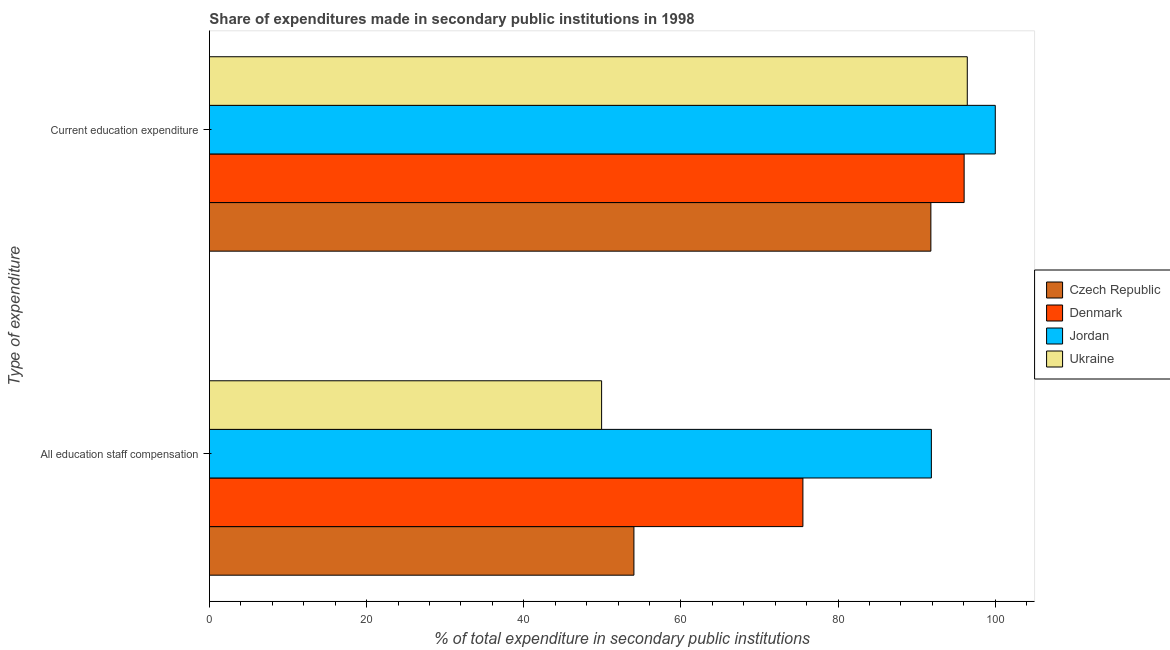How many different coloured bars are there?
Your answer should be very brief. 4. How many groups of bars are there?
Your answer should be very brief. 2. Are the number of bars on each tick of the Y-axis equal?
Ensure brevity in your answer.  Yes. How many bars are there on the 2nd tick from the top?
Your answer should be very brief. 4. How many bars are there on the 1st tick from the bottom?
Make the answer very short. 4. What is the label of the 1st group of bars from the top?
Your answer should be compact. Current education expenditure. What is the expenditure in staff compensation in Jordan?
Make the answer very short. 91.87. Across all countries, what is the minimum expenditure in education?
Make the answer very short. 91.8. In which country was the expenditure in education maximum?
Provide a short and direct response. Jordan. In which country was the expenditure in education minimum?
Make the answer very short. Czech Republic. What is the total expenditure in staff compensation in the graph?
Provide a succinct answer. 271.32. What is the difference between the expenditure in education in Czech Republic and that in Ukraine?
Provide a short and direct response. -4.63. What is the difference between the expenditure in education in Ukraine and the expenditure in staff compensation in Jordan?
Your answer should be compact. 4.57. What is the average expenditure in education per country?
Ensure brevity in your answer.  96.07. What is the difference between the expenditure in education and expenditure in staff compensation in Czech Republic?
Provide a short and direct response. 37.79. In how many countries, is the expenditure in staff compensation greater than 24 %?
Provide a short and direct response. 4. What is the ratio of the expenditure in staff compensation in Czech Republic to that in Ukraine?
Your answer should be compact. 1.08. Is the expenditure in staff compensation in Jordan less than that in Denmark?
Your answer should be very brief. No. In how many countries, is the expenditure in staff compensation greater than the average expenditure in staff compensation taken over all countries?
Keep it short and to the point. 2. Are the values on the major ticks of X-axis written in scientific E-notation?
Offer a very short reply. No. Where does the legend appear in the graph?
Provide a succinct answer. Center right. How many legend labels are there?
Ensure brevity in your answer.  4. What is the title of the graph?
Provide a short and direct response. Share of expenditures made in secondary public institutions in 1998. What is the label or title of the X-axis?
Provide a short and direct response. % of total expenditure in secondary public institutions. What is the label or title of the Y-axis?
Make the answer very short. Type of expenditure. What is the % of total expenditure in secondary public institutions in Czech Republic in All education staff compensation?
Ensure brevity in your answer.  54.02. What is the % of total expenditure in secondary public institutions of Denmark in All education staff compensation?
Offer a very short reply. 75.52. What is the % of total expenditure in secondary public institutions in Jordan in All education staff compensation?
Your response must be concise. 91.87. What is the % of total expenditure in secondary public institutions in Ukraine in All education staff compensation?
Offer a terse response. 49.91. What is the % of total expenditure in secondary public institutions of Czech Republic in Current education expenditure?
Ensure brevity in your answer.  91.8. What is the % of total expenditure in secondary public institutions of Denmark in Current education expenditure?
Make the answer very short. 96.04. What is the % of total expenditure in secondary public institutions of Ukraine in Current education expenditure?
Your answer should be very brief. 96.44. Across all Type of expenditure, what is the maximum % of total expenditure in secondary public institutions in Czech Republic?
Your answer should be very brief. 91.8. Across all Type of expenditure, what is the maximum % of total expenditure in secondary public institutions in Denmark?
Offer a terse response. 96.04. Across all Type of expenditure, what is the maximum % of total expenditure in secondary public institutions of Ukraine?
Offer a very short reply. 96.44. Across all Type of expenditure, what is the minimum % of total expenditure in secondary public institutions of Czech Republic?
Offer a terse response. 54.02. Across all Type of expenditure, what is the minimum % of total expenditure in secondary public institutions in Denmark?
Your answer should be compact. 75.52. Across all Type of expenditure, what is the minimum % of total expenditure in secondary public institutions of Jordan?
Provide a short and direct response. 91.87. Across all Type of expenditure, what is the minimum % of total expenditure in secondary public institutions in Ukraine?
Ensure brevity in your answer.  49.91. What is the total % of total expenditure in secondary public institutions of Czech Republic in the graph?
Your response must be concise. 145.82. What is the total % of total expenditure in secondary public institutions in Denmark in the graph?
Your answer should be compact. 171.56. What is the total % of total expenditure in secondary public institutions of Jordan in the graph?
Your answer should be compact. 191.87. What is the total % of total expenditure in secondary public institutions in Ukraine in the graph?
Ensure brevity in your answer.  146.35. What is the difference between the % of total expenditure in secondary public institutions of Czech Republic in All education staff compensation and that in Current education expenditure?
Your answer should be very brief. -37.79. What is the difference between the % of total expenditure in secondary public institutions in Denmark in All education staff compensation and that in Current education expenditure?
Provide a succinct answer. -20.52. What is the difference between the % of total expenditure in secondary public institutions in Jordan in All education staff compensation and that in Current education expenditure?
Offer a very short reply. -8.13. What is the difference between the % of total expenditure in secondary public institutions of Ukraine in All education staff compensation and that in Current education expenditure?
Your answer should be compact. -46.53. What is the difference between the % of total expenditure in secondary public institutions of Czech Republic in All education staff compensation and the % of total expenditure in secondary public institutions of Denmark in Current education expenditure?
Ensure brevity in your answer.  -42.02. What is the difference between the % of total expenditure in secondary public institutions of Czech Republic in All education staff compensation and the % of total expenditure in secondary public institutions of Jordan in Current education expenditure?
Your answer should be compact. -45.98. What is the difference between the % of total expenditure in secondary public institutions in Czech Republic in All education staff compensation and the % of total expenditure in secondary public institutions in Ukraine in Current education expenditure?
Your answer should be very brief. -42.42. What is the difference between the % of total expenditure in secondary public institutions of Denmark in All education staff compensation and the % of total expenditure in secondary public institutions of Jordan in Current education expenditure?
Your response must be concise. -24.48. What is the difference between the % of total expenditure in secondary public institutions of Denmark in All education staff compensation and the % of total expenditure in secondary public institutions of Ukraine in Current education expenditure?
Offer a very short reply. -20.92. What is the difference between the % of total expenditure in secondary public institutions of Jordan in All education staff compensation and the % of total expenditure in secondary public institutions of Ukraine in Current education expenditure?
Provide a short and direct response. -4.57. What is the average % of total expenditure in secondary public institutions in Czech Republic per Type of expenditure?
Offer a very short reply. 72.91. What is the average % of total expenditure in secondary public institutions of Denmark per Type of expenditure?
Give a very brief answer. 85.78. What is the average % of total expenditure in secondary public institutions in Jordan per Type of expenditure?
Provide a short and direct response. 95.93. What is the average % of total expenditure in secondary public institutions of Ukraine per Type of expenditure?
Your answer should be very brief. 73.17. What is the difference between the % of total expenditure in secondary public institutions in Czech Republic and % of total expenditure in secondary public institutions in Denmark in All education staff compensation?
Your response must be concise. -21.5. What is the difference between the % of total expenditure in secondary public institutions in Czech Republic and % of total expenditure in secondary public institutions in Jordan in All education staff compensation?
Provide a short and direct response. -37.85. What is the difference between the % of total expenditure in secondary public institutions of Czech Republic and % of total expenditure in secondary public institutions of Ukraine in All education staff compensation?
Ensure brevity in your answer.  4.11. What is the difference between the % of total expenditure in secondary public institutions in Denmark and % of total expenditure in secondary public institutions in Jordan in All education staff compensation?
Your answer should be very brief. -16.35. What is the difference between the % of total expenditure in secondary public institutions of Denmark and % of total expenditure in secondary public institutions of Ukraine in All education staff compensation?
Your answer should be compact. 25.61. What is the difference between the % of total expenditure in secondary public institutions in Jordan and % of total expenditure in secondary public institutions in Ukraine in All education staff compensation?
Ensure brevity in your answer.  41.96. What is the difference between the % of total expenditure in secondary public institutions in Czech Republic and % of total expenditure in secondary public institutions in Denmark in Current education expenditure?
Provide a succinct answer. -4.23. What is the difference between the % of total expenditure in secondary public institutions of Czech Republic and % of total expenditure in secondary public institutions of Jordan in Current education expenditure?
Offer a terse response. -8.2. What is the difference between the % of total expenditure in secondary public institutions in Czech Republic and % of total expenditure in secondary public institutions in Ukraine in Current education expenditure?
Ensure brevity in your answer.  -4.63. What is the difference between the % of total expenditure in secondary public institutions in Denmark and % of total expenditure in secondary public institutions in Jordan in Current education expenditure?
Give a very brief answer. -3.96. What is the difference between the % of total expenditure in secondary public institutions of Denmark and % of total expenditure in secondary public institutions of Ukraine in Current education expenditure?
Provide a short and direct response. -0.4. What is the difference between the % of total expenditure in secondary public institutions of Jordan and % of total expenditure in secondary public institutions of Ukraine in Current education expenditure?
Give a very brief answer. 3.56. What is the ratio of the % of total expenditure in secondary public institutions of Czech Republic in All education staff compensation to that in Current education expenditure?
Your answer should be compact. 0.59. What is the ratio of the % of total expenditure in secondary public institutions in Denmark in All education staff compensation to that in Current education expenditure?
Offer a very short reply. 0.79. What is the ratio of the % of total expenditure in secondary public institutions in Jordan in All education staff compensation to that in Current education expenditure?
Provide a short and direct response. 0.92. What is the ratio of the % of total expenditure in secondary public institutions in Ukraine in All education staff compensation to that in Current education expenditure?
Your response must be concise. 0.52. What is the difference between the highest and the second highest % of total expenditure in secondary public institutions in Czech Republic?
Your answer should be compact. 37.79. What is the difference between the highest and the second highest % of total expenditure in secondary public institutions in Denmark?
Offer a very short reply. 20.52. What is the difference between the highest and the second highest % of total expenditure in secondary public institutions in Jordan?
Your answer should be compact. 8.13. What is the difference between the highest and the second highest % of total expenditure in secondary public institutions in Ukraine?
Offer a very short reply. 46.53. What is the difference between the highest and the lowest % of total expenditure in secondary public institutions in Czech Republic?
Your response must be concise. 37.79. What is the difference between the highest and the lowest % of total expenditure in secondary public institutions of Denmark?
Make the answer very short. 20.52. What is the difference between the highest and the lowest % of total expenditure in secondary public institutions of Jordan?
Provide a short and direct response. 8.13. What is the difference between the highest and the lowest % of total expenditure in secondary public institutions in Ukraine?
Offer a very short reply. 46.53. 